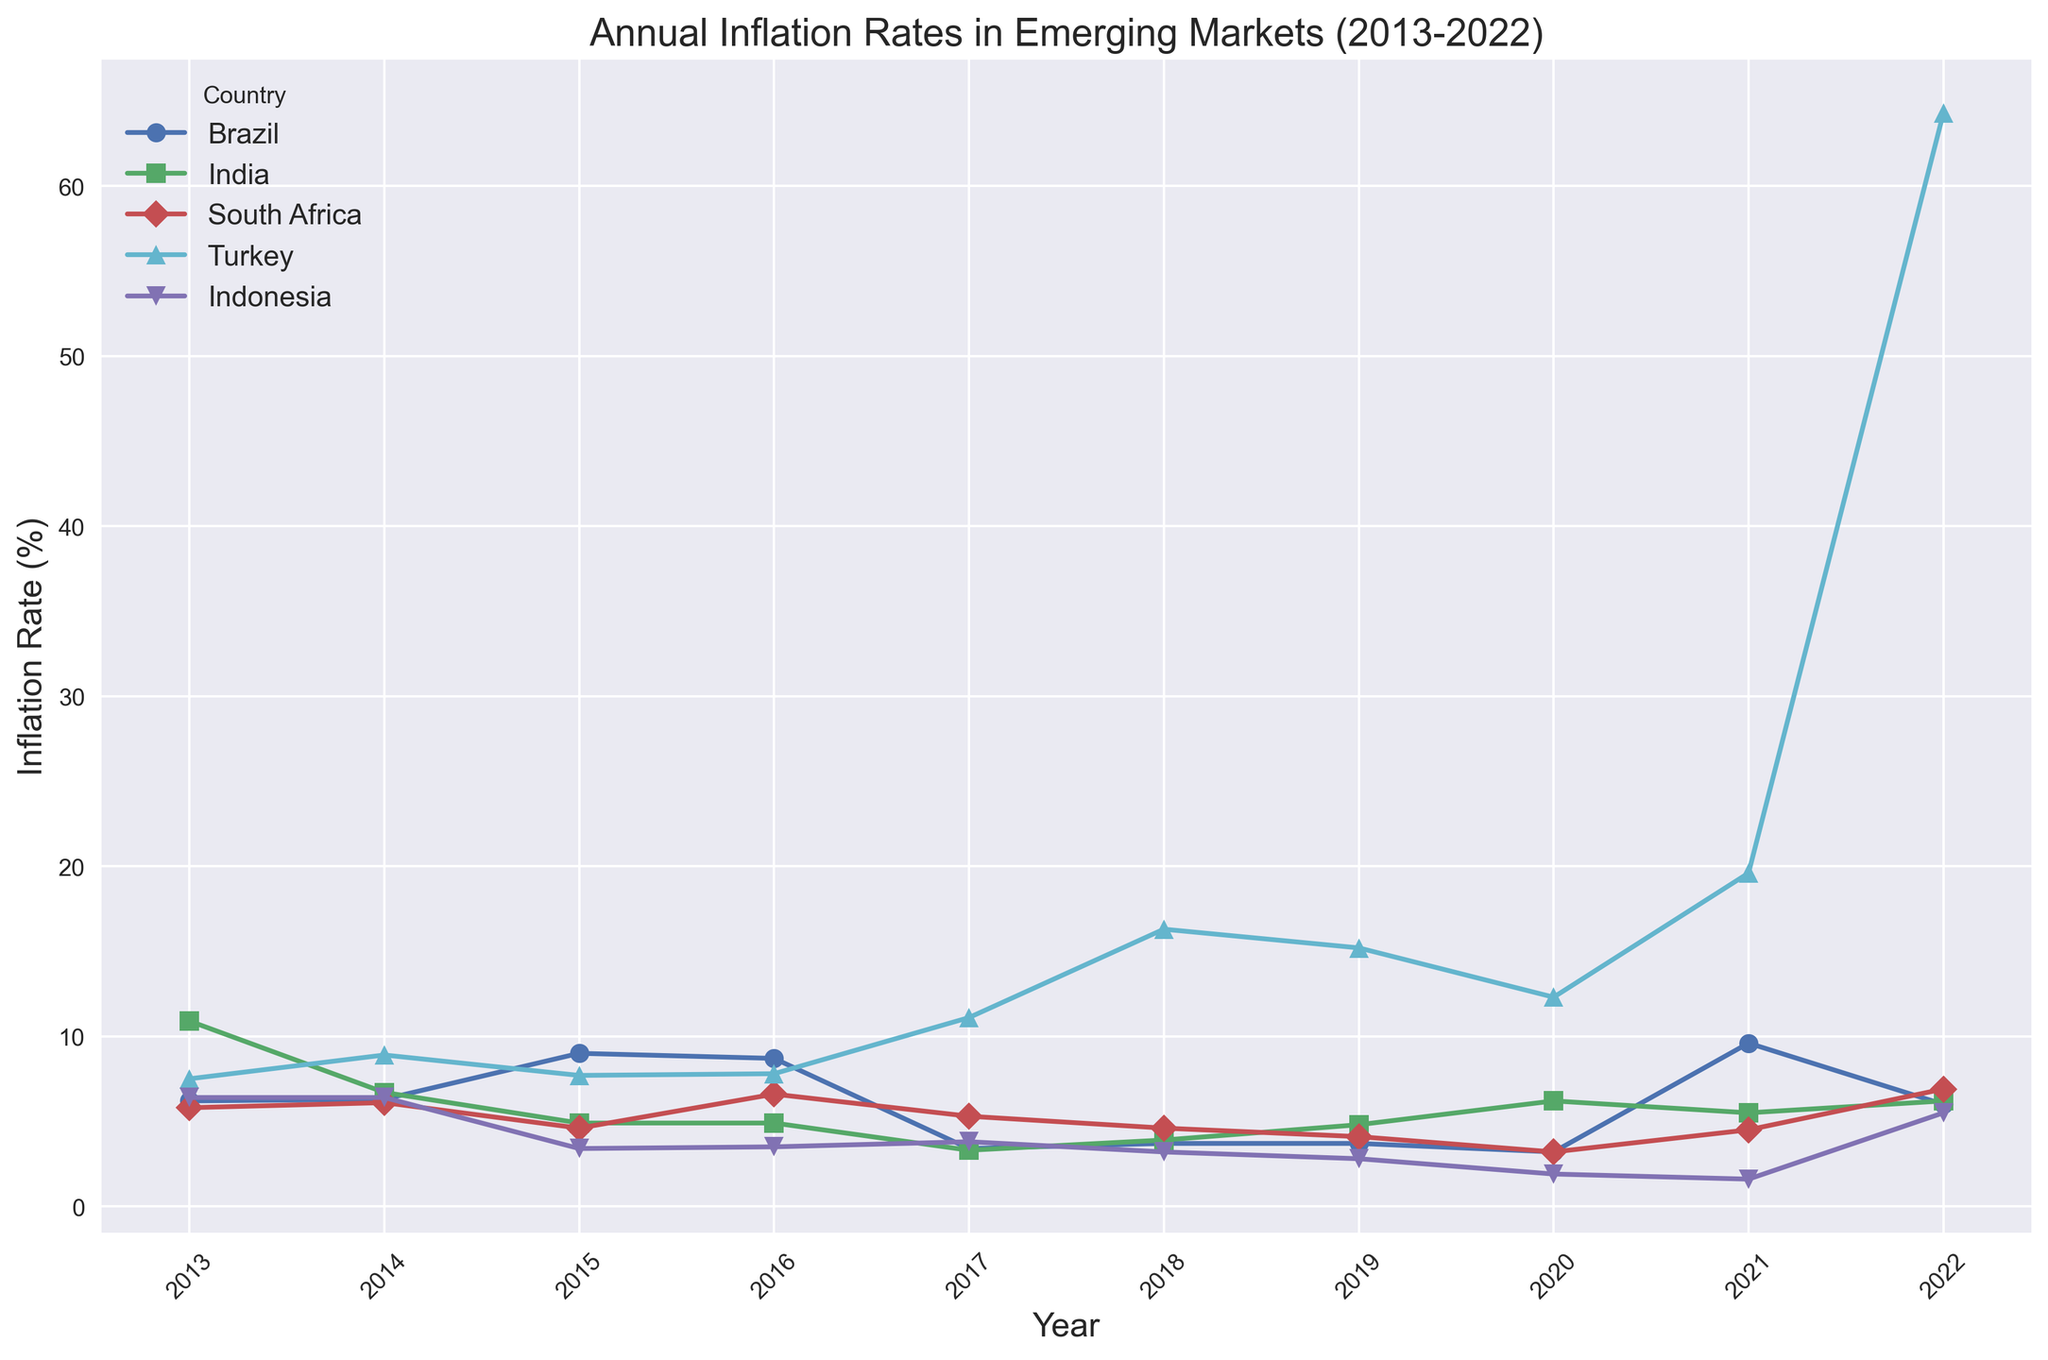Which country had the highest inflation rate in 2022? In 2022, Turkey's inflation rate is the highest among all countries, at 64.3%.
Answer: Turkey Which country experienced the largest drop in inflation rate from 2021 to 2022? Observe the change in inflation rates from 2021 to 2022 for each country. Brazil decreased from 9.6% to 6.0%, India from 5.5% to 6.2%, South Africa from 4.5% to 6.9%, Turkey from 19.6% to 64.3%, and Indonesia from 1.6% to 5.5%. Brazil had the largest drop, decreasing by 3.6%.
Answer: Brazil Which country had the most consistent inflation rate from 2013 to 2022? Consistent inflation rates would show small variations over the decade. By inspecting the lines, Indonesia seems to show the least fluctuation, staying within the range of around 1.6% to 6.4%.
Answer: Indonesia Between 2018 and 2019, which country had the smallest change in inflation rate? From 2018 to 2019, compare the inflation rates: Brazil (3.7% - 3.7%), India (4.8% - 3.9%), South Africa (4.6% - 4.1%), Turkey (16.3% - 15.2%), and Indonesia (3.2% - 2.8%). The smallest change is seen in Brazil, with no change.
Answer: Brazil During which year did Turkey experience a dramatic increase in inflation rate? Identify the years where Turkey's inflation rate spikes significantly. A notable increase is observed from 2021 (19.6%) to 2022 (64.3%).
Answer: 2022 Which country experienced the highest inflation rate in 2013? By comparing the inflation rates for 2013, India had the highest inflation rate at 10.9%.
Answer: India What is the median inflation rate for South Africa over the decade? The inflation rates for South Africa from 2013 to 2022 are: [5.8, 6.1, 4.6, 6.6, 5.3, 4.6, 4.1, 3.2, 4.5, 6.9]. Sorting these: [3.2, 4.1, 4.5, 4.6, 4.6, 5.3, 5.8, 6.1, 6.6, 6.9]. The median is the average of the 5th and 6th values: (4.6 + 5.3) / 2 = 4.95.
Answer: 4.95 Between which consecutive years did Brazil experience the largest increase in inflation rate? Reviewing Brazil's inflation rates: 2013 (6.2%), 2014 (6.3%), 2015 (9.0%), 2016 (8.7%), 2017 (3.4%), 2018 (3.7%), 2019 (3.7%), 2020 (3.2%), 2021 (9.6%), 2022 (6.0%), the largest increase is from 2020 (3.2%) to 2021 (9.6%), an increase of 6.4%.
Answer: 2020-2021 Which two countries' inflation rates converged closest together in 2018? Examining 2018 rates: Brazil (3.7%), India (4.8%), South Africa (4.6%), Turkey (16.3%), Indonesia (3.2%). Brazil and South Africa have the closest rates: 3.7% and 4.6%, a difference of 0.9%.
Answer: Brazil and South Africa 